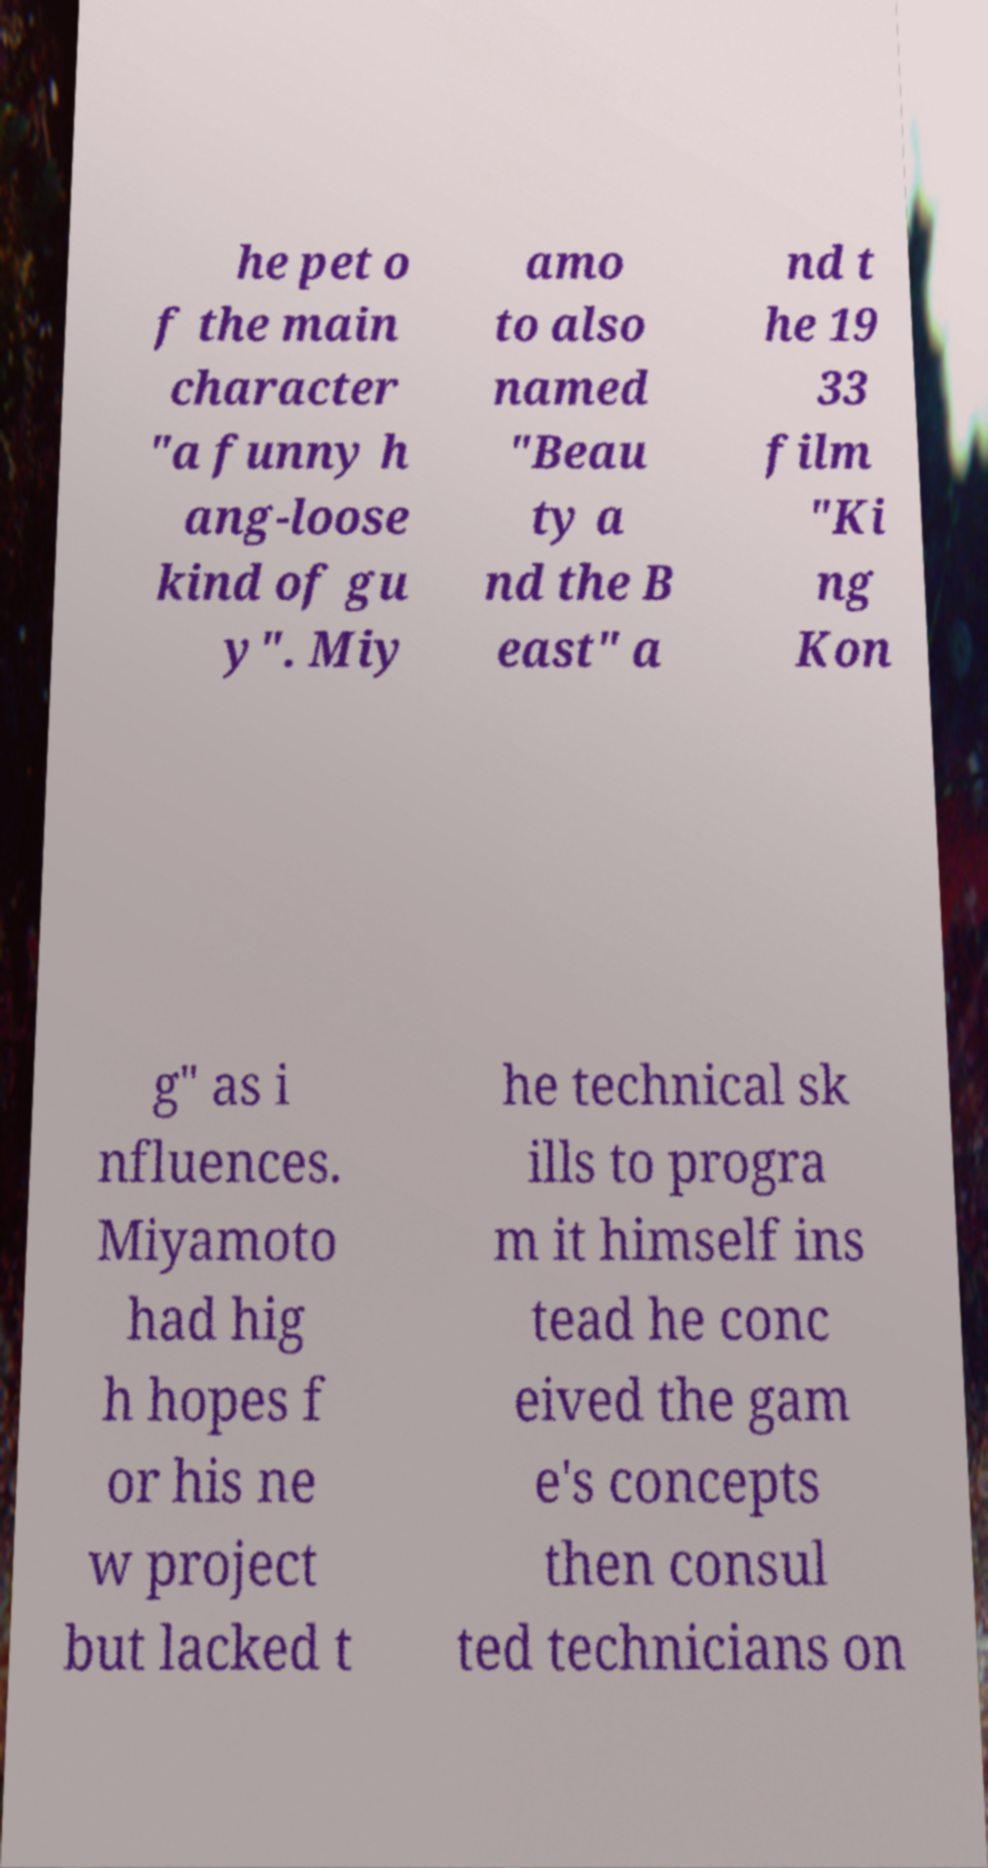Can you accurately transcribe the text from the provided image for me? he pet o f the main character "a funny h ang-loose kind of gu y". Miy amo to also named "Beau ty a nd the B east" a nd t he 19 33 film "Ki ng Kon g" as i nfluences. Miyamoto had hig h hopes f or his ne w project but lacked t he technical sk ills to progra m it himself ins tead he conc eived the gam e's concepts then consul ted technicians on 